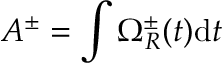Convert formula to latex. <formula><loc_0><loc_0><loc_500><loc_500>A ^ { \pm } = \int \Omega _ { R } ^ { \pm } ( t ) d t</formula> 